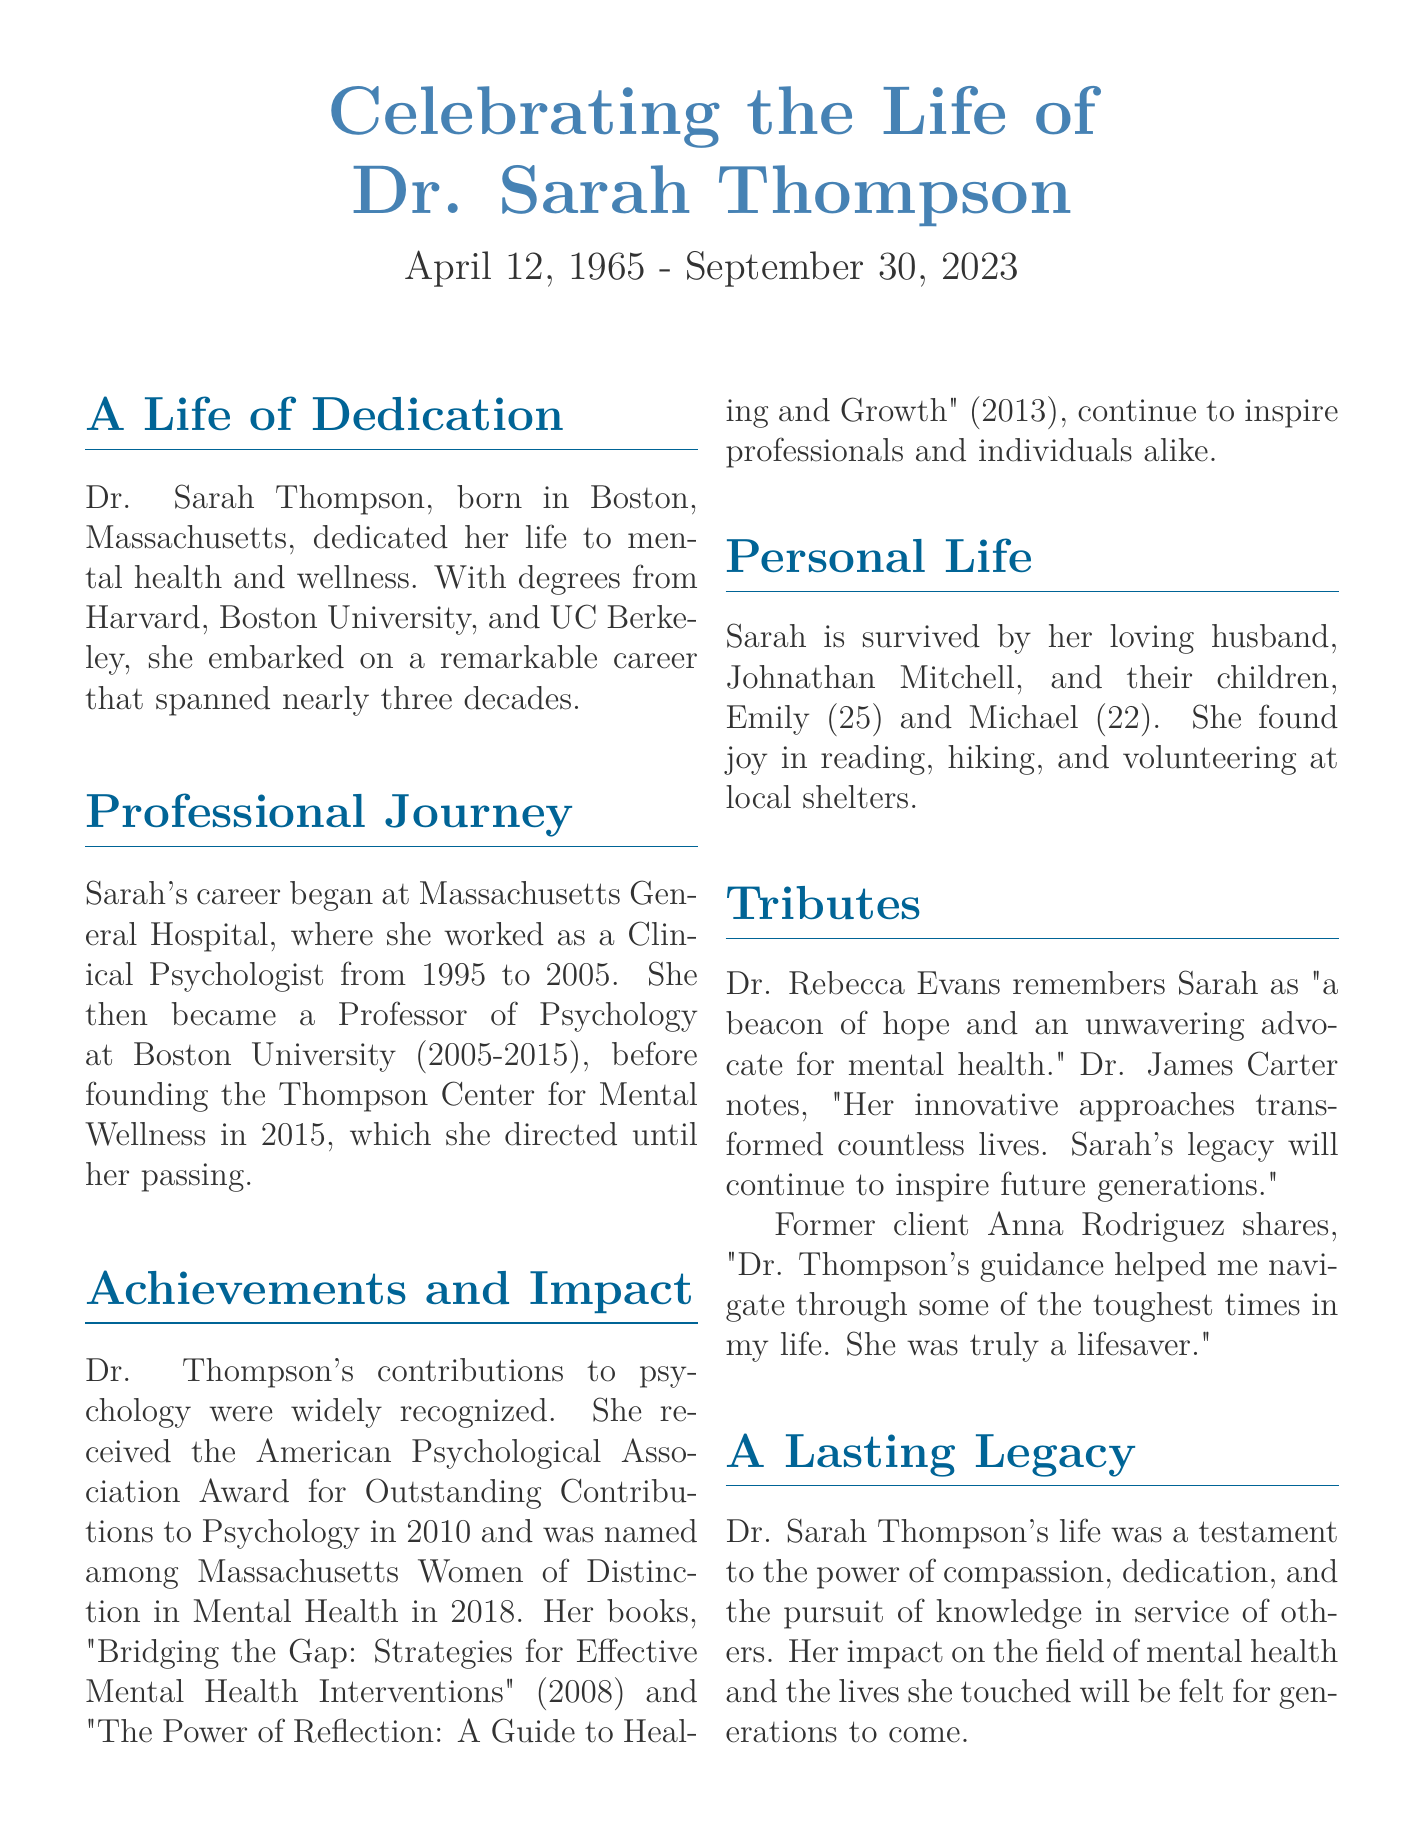what was Dr. Sarah Thompson's profession? Dr. Sarah Thompson was a Clinical Psychologist and later a Professor of Psychology.
Answer: Clinical Psychologist when did Dr. Thompson begin her career? Dr. Thompson began her career at Massachusetts General Hospital in 1995.
Answer: 1995 what is the name of the center Dr. Thompson founded? The center that Dr. Thompson founded is called the Thompson Center for Mental Wellness.
Answer: Thompson Center for Mental Wellness which award did Dr. Thompson receive in 2010? In 2010, Dr. Thompson received the American Psychological Association Award for Outstanding Contributions to Psychology.
Answer: American Psychological Association Award how many children did Dr. Thompson have? Dr. Thompson had two children, Emily and Michael.
Answer: two who is Dr. Thompson's husband? Dr. Thompson's husband is Johnathan Mitchell.
Answer: Johnathan Mitchell which book did Dr. Thompson publish in 2008? Dr. Thompson published the book "Bridging the Gap: Strategies for Effective Mental Health Interventions" in 2008.
Answer: "Bridging the Gap: Strategies for Effective Mental Health Interventions" what did Dr. Rebecca Evans describe Dr. Thompson as? Dr. Rebecca Evans described Dr. Thompson as "a beacon of hope and an unwavering advocate for mental health."
Answer: a beacon of hope what did Sarah enjoy besides her professional work? Besides her professional work, Sarah enjoyed reading, hiking, and volunteering at local shelters.
Answer: reading, hiking, volunteering 